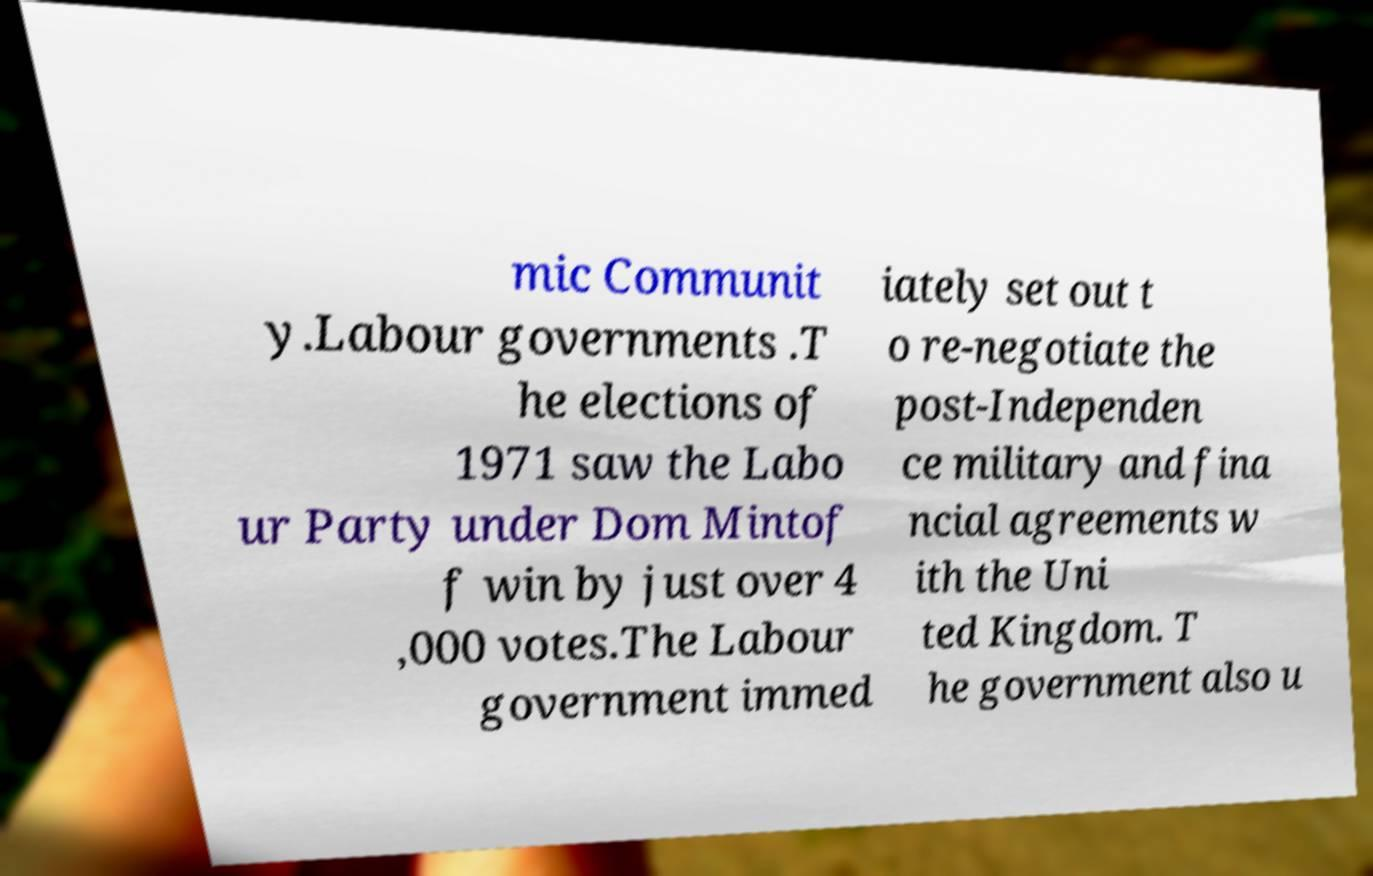What messages or text are displayed in this image? I need them in a readable, typed format. mic Communit y.Labour governments .T he elections of 1971 saw the Labo ur Party under Dom Mintof f win by just over 4 ,000 votes.The Labour government immed iately set out t o re-negotiate the post-Independen ce military and fina ncial agreements w ith the Uni ted Kingdom. T he government also u 